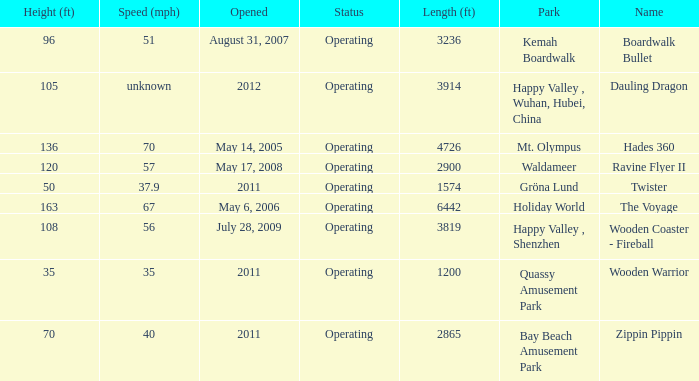How extensive is the kemah boardwalk roller coaster? 3236.0. 